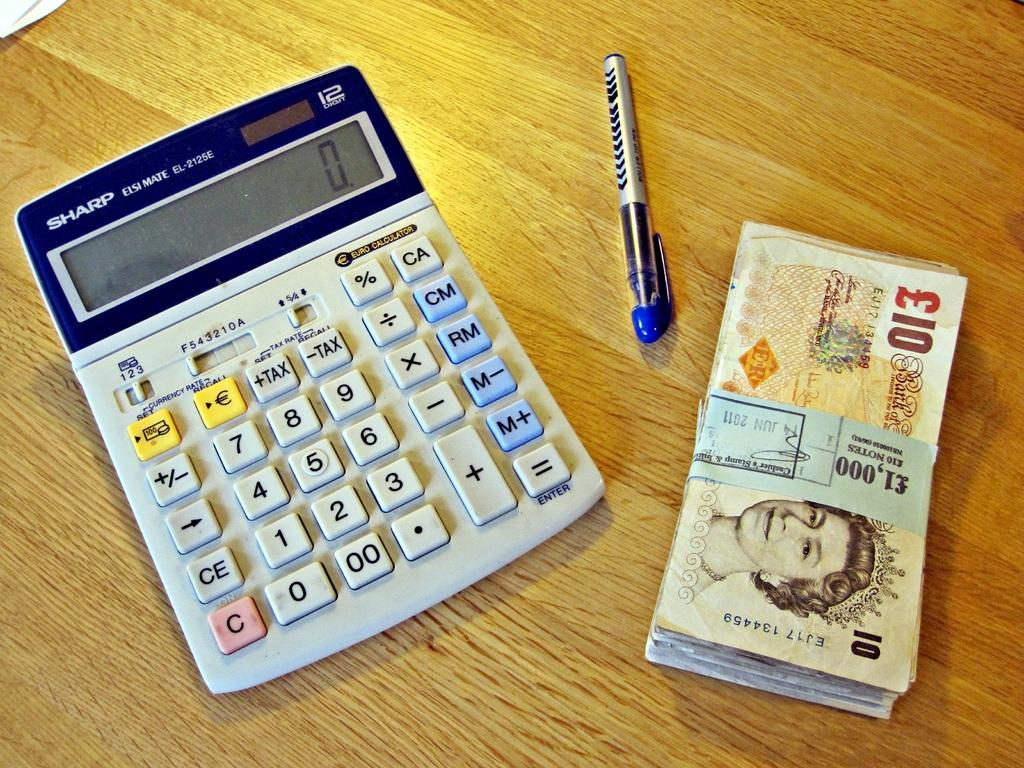<image>
Relay a brief, clear account of the picture shown. A Sharp calculator sits on a table next to a stack of 100 10 pound notes. 